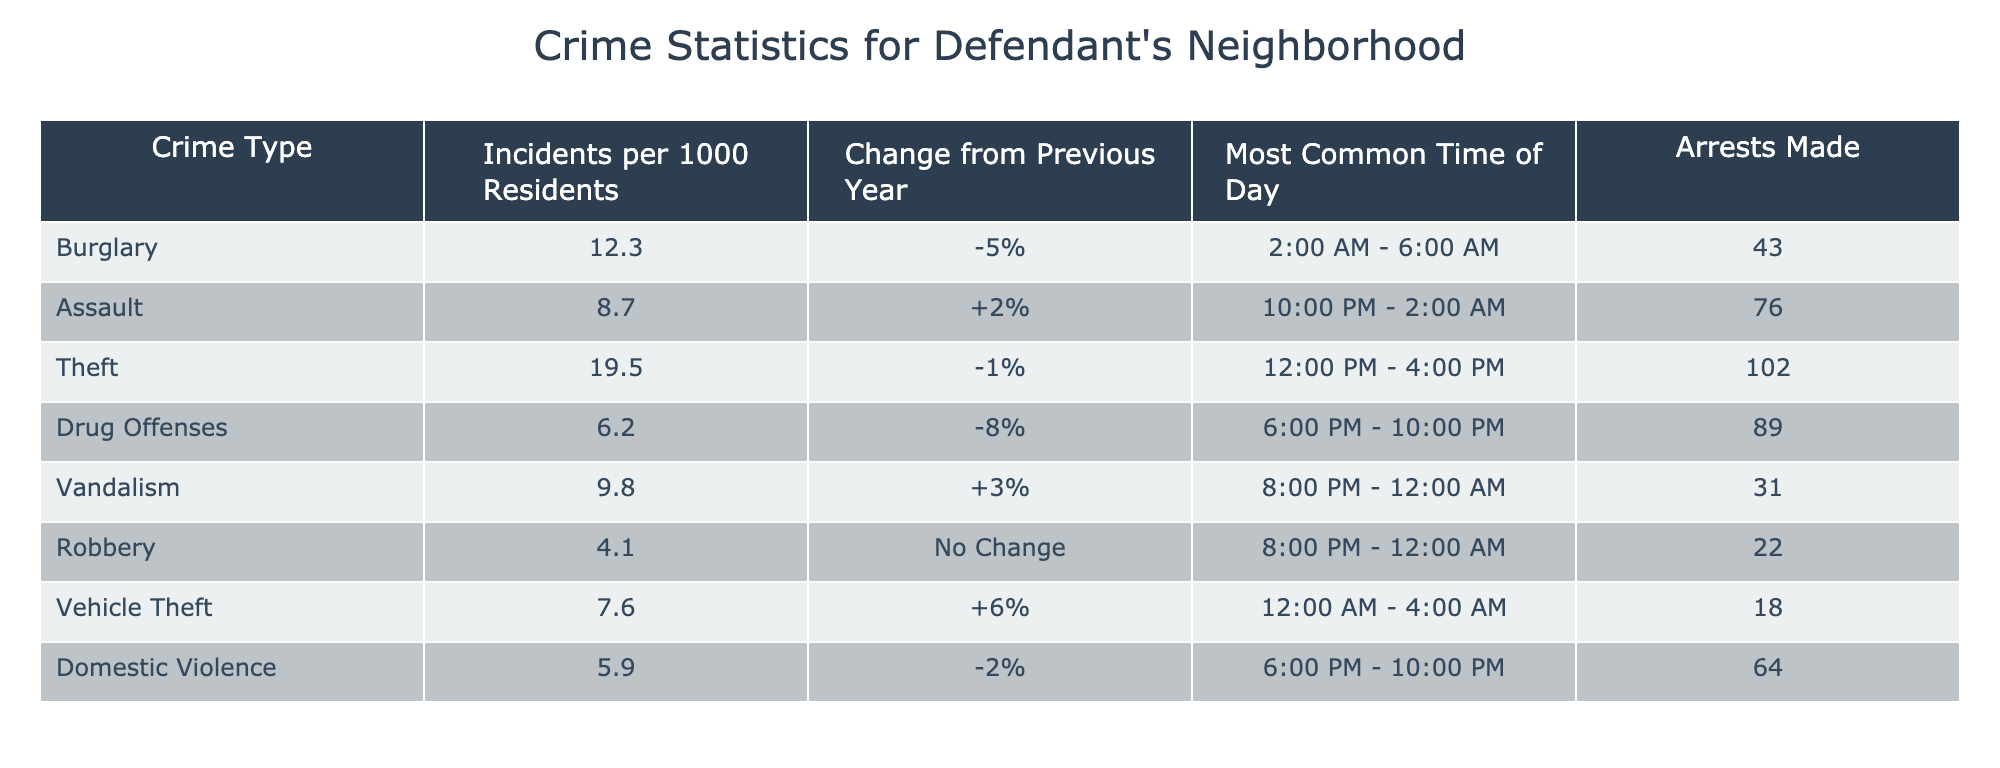What is the most common time of day for theft incidents? The table lists the most common times for each crime type. Looking at the row for theft, it shows the most common time is between 12:00 PM and 4:00 PM.
Answer: 12:00 PM - 4:00 PM How many assault incidents were reported per 1000 residents? The table indicates the number of assault incidents per 1000 residents in the respective row, which shows that there were 8.7 incidents per 1000 residents for assault.
Answer: 8.7 Is there an increase or decrease in vehicle theft incidents compared to the previous year? The table indicates that vehicle theft has seen a change of +6%, meaning there was an increase in incidents compared to the previous year.
Answer: Yes What is the total number of arrests made for drug offenses and domestic violence combined? To find the total, we add the number of arrests for drug offenses (89) and domestic violence (64). The sum is 89 + 64 = 153.
Answer: 153 What crime type had the highest number of incidents per 1000 residents? By comparing the values in the "Incidents per 1000 Residents" column, theft at 19.5 incidents is the highest among all listed crime types.
Answer: Theft Was there a change from the previous year in vandalism incidents? The table shows vandalism has a change of +3%, indicating an increase from the previous year, so the answer is yes.
Answer: Yes What is the average number of arrests made across all crime types listed? First, we sum the total arrests: 43 (Burglary) + 76 (Assault) + 102 (Theft) + 89 (Drug Offenses) + 31 (Vandalism) + 22 (Robbery) + 18 (Vehicle Theft) + 64 (Domestic Violence) = 405. Then, we divide by the number of crime types (8), resulting in an average of 405 / 8 = 50.625, which we can round to 51 for simplicity.
Answer: 51 For which crime type was there no change in incidents from the previous year? By examining the "Change from Previous Year" column, robbery shows "No Change," indicating that there was no variation in incidents from the prior year.
Answer: Robbery What crime had the lowest number of incidents per 1000 residents? In the "Incidents per 1000 Residents" column, robbery has the lowest value at 4.1.
Answer: Robbery 